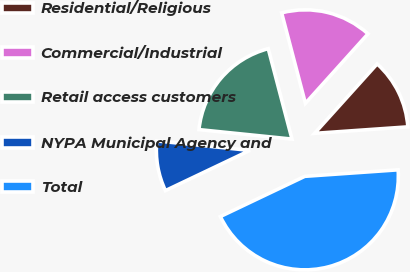Convert chart. <chart><loc_0><loc_0><loc_500><loc_500><pie_chart><fcel>Residential/Religious<fcel>Commercial/Industrial<fcel>Retail access customers<fcel>NYPA Municipal Agency and<fcel>Total<nl><fcel>12.22%<fcel>15.76%<fcel>19.29%<fcel>8.69%<fcel>44.03%<nl></chart> 